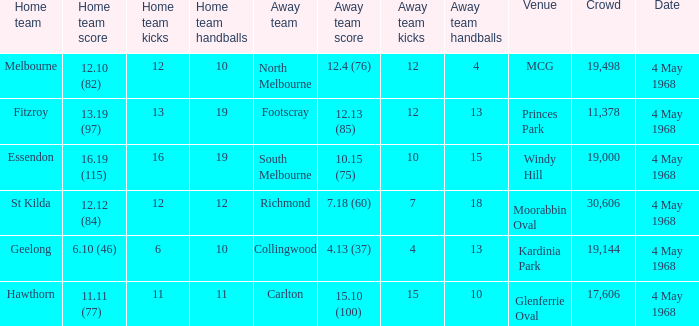What team played at Moorabbin Oval to a crowd of 19,144? St Kilda. 